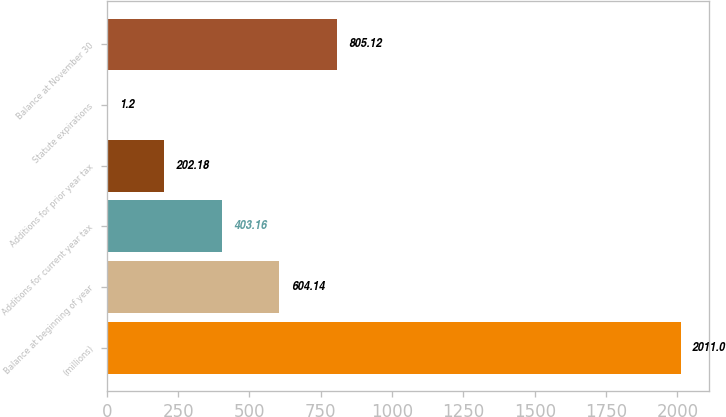<chart> <loc_0><loc_0><loc_500><loc_500><bar_chart><fcel>(millions)<fcel>Balance at beginning of year<fcel>Additions for current year tax<fcel>Additions for prior year tax<fcel>Statute expirations<fcel>Balance at November 30<nl><fcel>2011<fcel>604.14<fcel>403.16<fcel>202.18<fcel>1.2<fcel>805.12<nl></chart> 